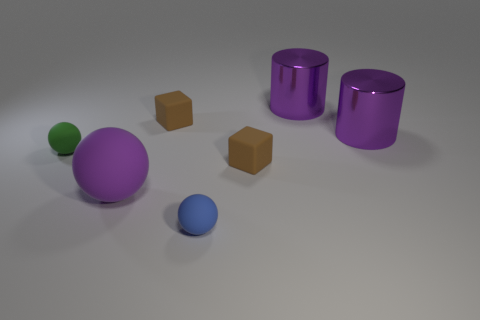Are the blue sphere and the big ball in front of the green object made of the same material?
Offer a terse response. Yes. The small matte block that is left of the small blue thing that is in front of the tiny rubber sphere behind the purple matte sphere is what color?
Offer a terse response. Brown. Is there any other thing that has the same size as the blue rubber ball?
Provide a succinct answer. Yes. There is a large ball; is its color the same as the tiny matte sphere that is behind the big purple rubber object?
Your answer should be very brief. No. The big rubber object is what color?
Provide a succinct answer. Purple. There is a big object that is in front of the tiny green thing that is behind the tiny brown block that is to the right of the small blue matte sphere; what shape is it?
Offer a very short reply. Sphere. What number of other objects are there of the same color as the big sphere?
Give a very brief answer. 2. Is the number of tiny green spheres that are left of the tiny green matte object greater than the number of small green balls behind the tiny blue rubber object?
Offer a terse response. No. Are there any matte cubes in front of the large purple sphere?
Provide a succinct answer. No. The tiny object that is in front of the green rubber ball and behind the big sphere is made of what material?
Provide a short and direct response. Rubber. 